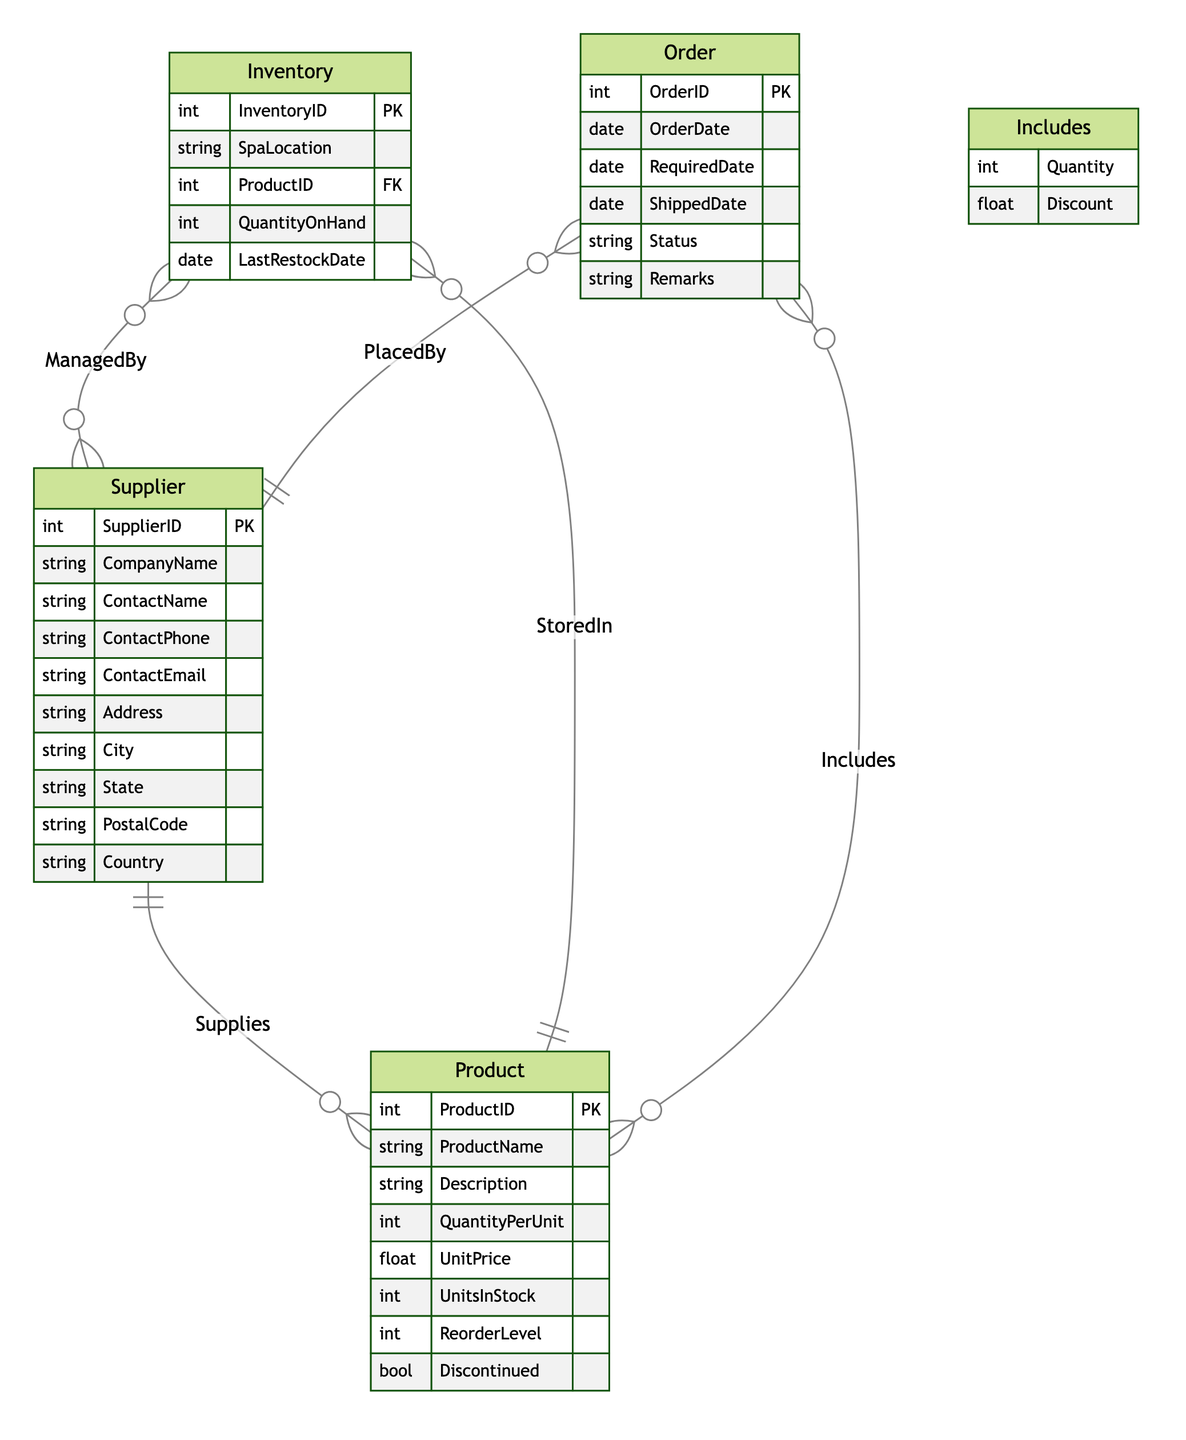What is the maximum number of products that a supplier can supply? The diagram shows a "Supplies" relationship between "Supplier" and "Product" with a cardinality of "1:N". This means one supplier can supply many products, so the maximum is theoretically unlimited unless specified.
Answer: Unlimited How many attributes does the "Product" entity have? The "Product" entity has the following attributes: ProductID, ProductName, Description, QuantityPerUnit, UnitPrice, UnitsInStock, ReorderLevel, and Discontinued. Counting these gives us a total of 8 attributes.
Answer: 8 Which entity is managed by multiple suppliers? The "Inventory" entity has a relationship called "ManagedBy" with "Supplier" denoting a cardinality of "N:M". This indicates that multiple suppliers can manage one inventory.
Answer: Inventory What relationship connects "Supplier" and "Order"? The relationship named "PlacedBy" connects the "Supplier" and "Order" entities. It has a cardinality of "1:N", meaning that one supplier can place multiple orders.
Answer: PlacedBy How many suppliers can supply a specific product? According to the "Supplies" relationship in the diagram, the cardinality is "1:N", which means a specific product can be supplied by only one supplier.
Answer: One What is the relationship between "Inventory" and "Product"? The relationship is called "StoredIn" which has a cardinality of "M:1". This means that multiple inventory entries can contain the same product, but each inventory entry refers to one specific product.
Answer: StoredIn How many entities are there in the diagram? The diagram lists three main entities: "Supplier", "Product", and "Inventory", along with an associative entity called "Order". This totals to four entities when counted.
Answer: Four How many attributes does the "Order" entity have? The "Order" entity attributes include: OrderID, OrderDate, RequiredDate, ShippedDate, Status, and Remarks. Counting these gives us a total of 6 attributes.
Answer: 6 What type of relationship is "Includes"? The relationship "Includes" represents an associative relationship between "Order" and "Product" with a cardinality of "M:N", indicating many orders can include many products.
Answer: Associative 